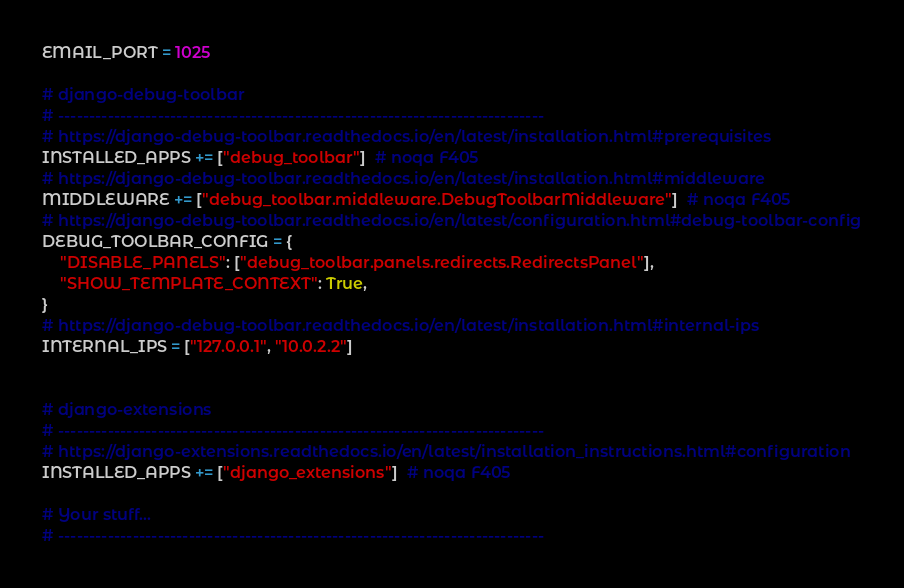Convert code to text. <code><loc_0><loc_0><loc_500><loc_500><_Python_>EMAIL_PORT = 1025

# django-debug-toolbar
# ------------------------------------------------------------------------------
# https://django-debug-toolbar.readthedocs.io/en/latest/installation.html#prerequisites
INSTALLED_APPS += ["debug_toolbar"]  # noqa F405
# https://django-debug-toolbar.readthedocs.io/en/latest/installation.html#middleware
MIDDLEWARE += ["debug_toolbar.middleware.DebugToolbarMiddleware"]  # noqa F405
# https://django-debug-toolbar.readthedocs.io/en/latest/configuration.html#debug-toolbar-config
DEBUG_TOOLBAR_CONFIG = {
    "DISABLE_PANELS": ["debug_toolbar.panels.redirects.RedirectsPanel"],
    "SHOW_TEMPLATE_CONTEXT": True,
}
# https://django-debug-toolbar.readthedocs.io/en/latest/installation.html#internal-ips
INTERNAL_IPS = ["127.0.0.1", "10.0.2.2"]


# django-extensions
# ------------------------------------------------------------------------------
# https://django-extensions.readthedocs.io/en/latest/installation_instructions.html#configuration
INSTALLED_APPS += ["django_extensions"]  # noqa F405

# Your stuff...
# ------------------------------------------------------------------------------
</code> 